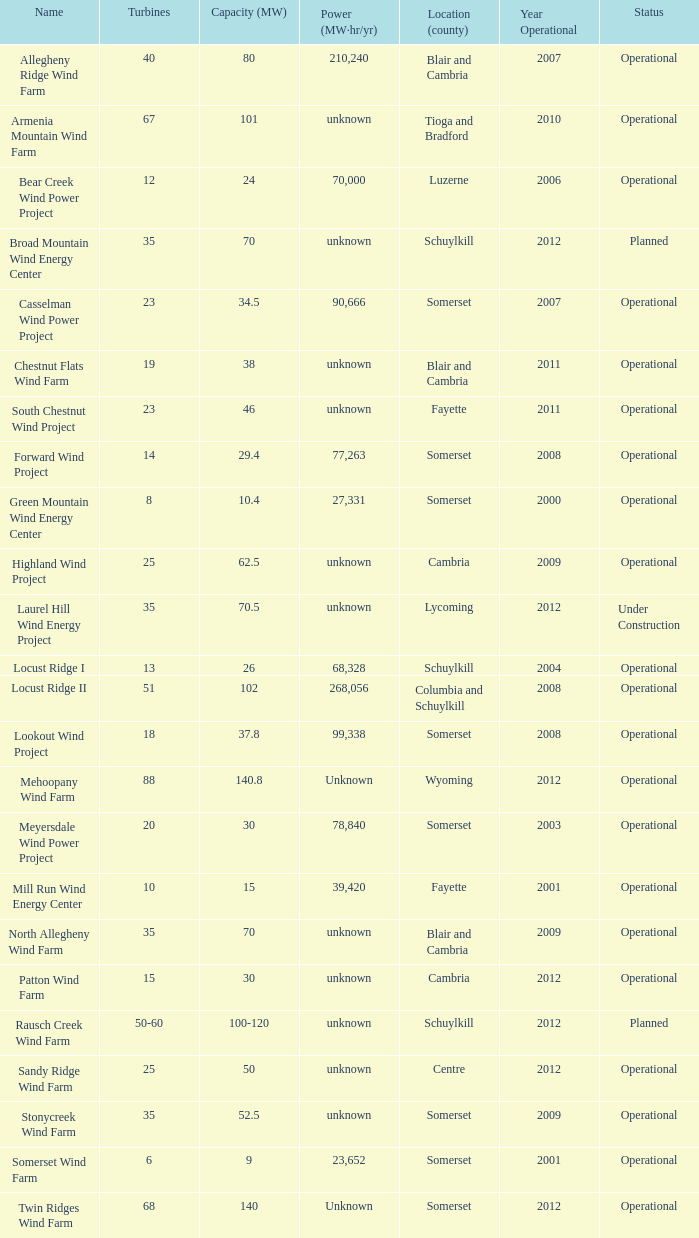What is the name of the farm that has a 70 capacity and is in operation? North Allegheny Wind Farm. 